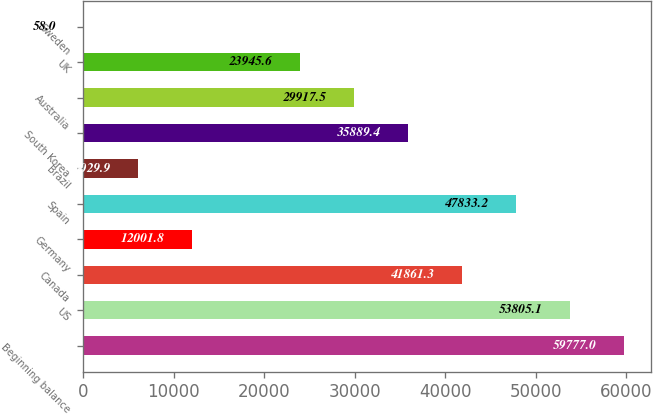<chart> <loc_0><loc_0><loc_500><loc_500><bar_chart><fcel>Beginning balance<fcel>US<fcel>Canada<fcel>Germany<fcel>Spain<fcel>Brazil<fcel>South Korea<fcel>Australia<fcel>UK<fcel>Sweden<nl><fcel>59777<fcel>53805.1<fcel>41861.3<fcel>12001.8<fcel>47833.2<fcel>6029.9<fcel>35889.4<fcel>29917.5<fcel>23945.6<fcel>58<nl></chart> 